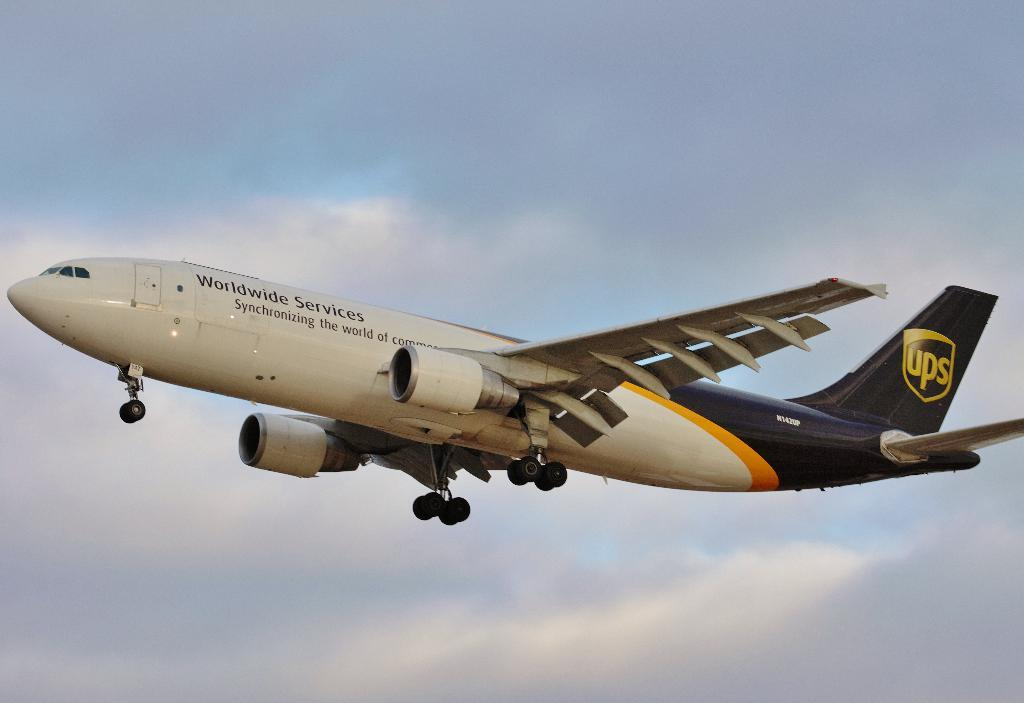What is the main subject of the image? The main subject of the image is an aircraft. What can be seen in the background of the image? The sky is visible in the background of the image. What is the condition of the sky in the image? There are clouds in the sky in the image. How many men are riding bikes in the image? There are no men or bikes present in the image; it features an aircraft and clouds in the sky. 